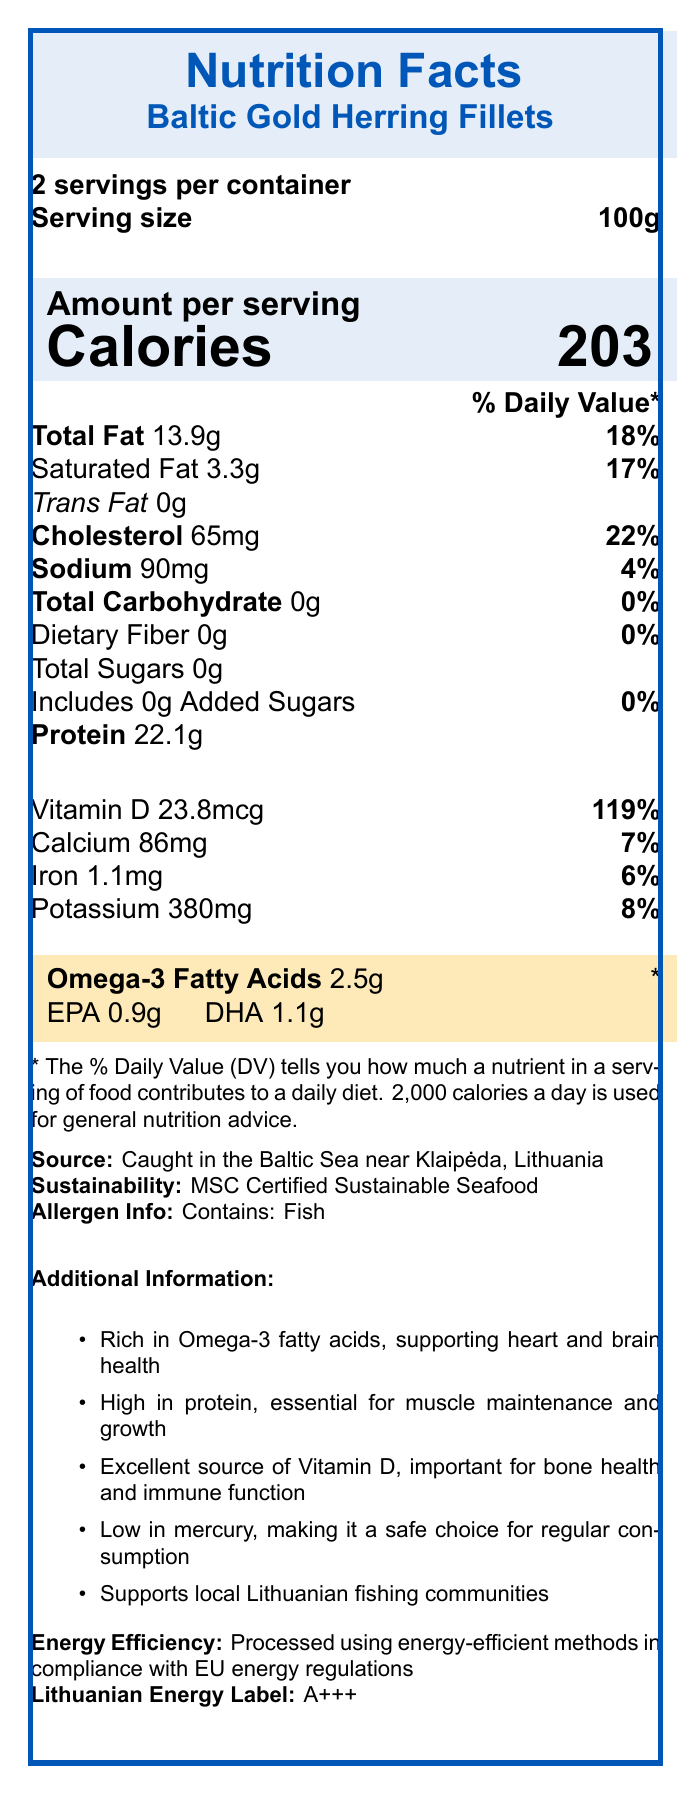who caught the Baltic Gold Herring Fillets? The document states that the herring was caught in the Baltic Sea near Klaipėda, Lithuania.
Answer: Caught in the Baltic Sea near Klaipėda, Lithuania how much saturated fat is in one serving? The document indicates that there is 3.3g of saturated fat per serving.
Answer: 3.3g how many servings are in one container? The document specifies that there are 2 servings per container.
Answer: 2 servings per container what is the vitamin D content in one serving? The document notes that the vitamin D content in one serving is 23.8mcg.
Answer: 23.8mcg what is the main source of protein in the product? "Baltic Gold Herring Fillets" can be inferred as the main source of protein.
Answer: Herring fillets what percentage of Daily Value of Vitamin D does one serving provide? The document indicates that one serving provides 119% of the Daily Value for Vitamin D.
Answer: 119% what is the sustainability certification mentioned? The document mentions that the product is MSC Certified Sustainable Seafood.
Answer: MSC Certified Sustainable Seafood which of the following nutrients has the highest percentage of Daily Value per serving?
A. Vitamin D
B. Cholesterol
C. Iron Vitamin D has the highest percentage Daily Value per serving at 119%.
Answer: A. Vitamin D how much omega-3 fatty acids are in one serving? 
A. 1.1g
B. 0.9g
C. 2.5g The document specifies that each serving contains 2.5g of omega-3 fatty acids.
Answer: C. 2.5g is the product free from added sugars? The document indicates that the product contains 0 grams of added sugars.
Answer: Yes describe the main idea of the document. The document offers a comprehensive overview of the Baltic Gold Herring Fillets, including nutritional facts, health benefits, and additional details about sustainable sourcing and local economic support.
Answer: The document provides detailed nutritional information about Baltic Gold Herring Fillets, highlighting their high omega-3 content and other nutrients, along with information on sourcing, sustainability, and energy efficiency. can the document tell us how the herring was caught? The document provides the location and sustainability of the catch but does not detail the methods used to catch the herring.
Answer: Cannot be determined does the product support local Lithuanian communities? The document mentions that the product supports local Lithuanian fishing communities.
Answer: Yes 